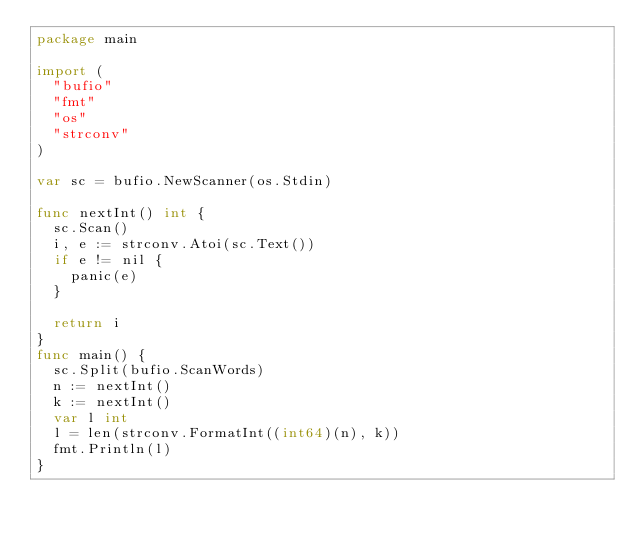Convert code to text. <code><loc_0><loc_0><loc_500><loc_500><_Go_>package main

import (
	"bufio"
	"fmt"
	"os"
	"strconv"
)

var sc = bufio.NewScanner(os.Stdin)

func nextInt() int {
	sc.Scan()
	i, e := strconv.Atoi(sc.Text())
	if e != nil {
		panic(e)
	}

	return i
}
func main() {
	sc.Split(bufio.ScanWords)
	n := nextInt()
	k := nextInt()
	var l int
	l = len(strconv.FormatInt((int64)(n), k))
	fmt.Println(l)
}
</code> 